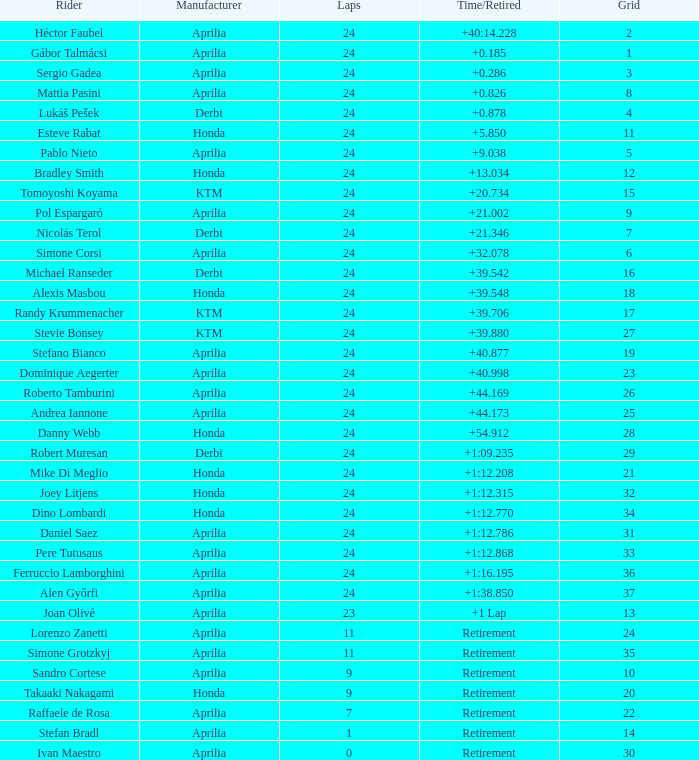Who manufactured the motorcycle that did 24 laps and 9 grids? Aprilia. 